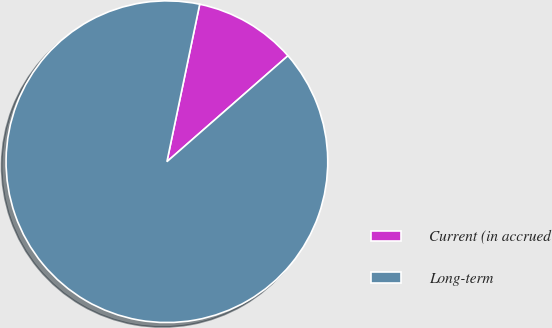Convert chart. <chart><loc_0><loc_0><loc_500><loc_500><pie_chart><fcel>Current (in accrued<fcel>Long-term<nl><fcel>10.29%<fcel>89.71%<nl></chart> 